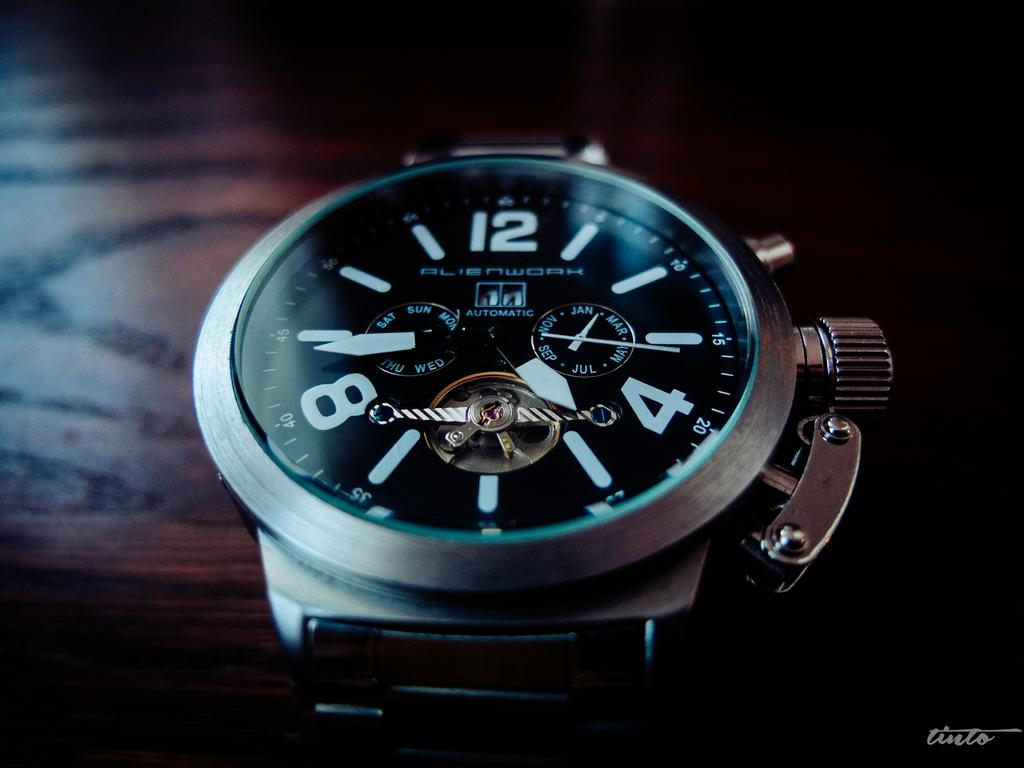<image>
Give a short and clear explanation of the subsequent image. A fancy watch that made by the brand Alienwork. 